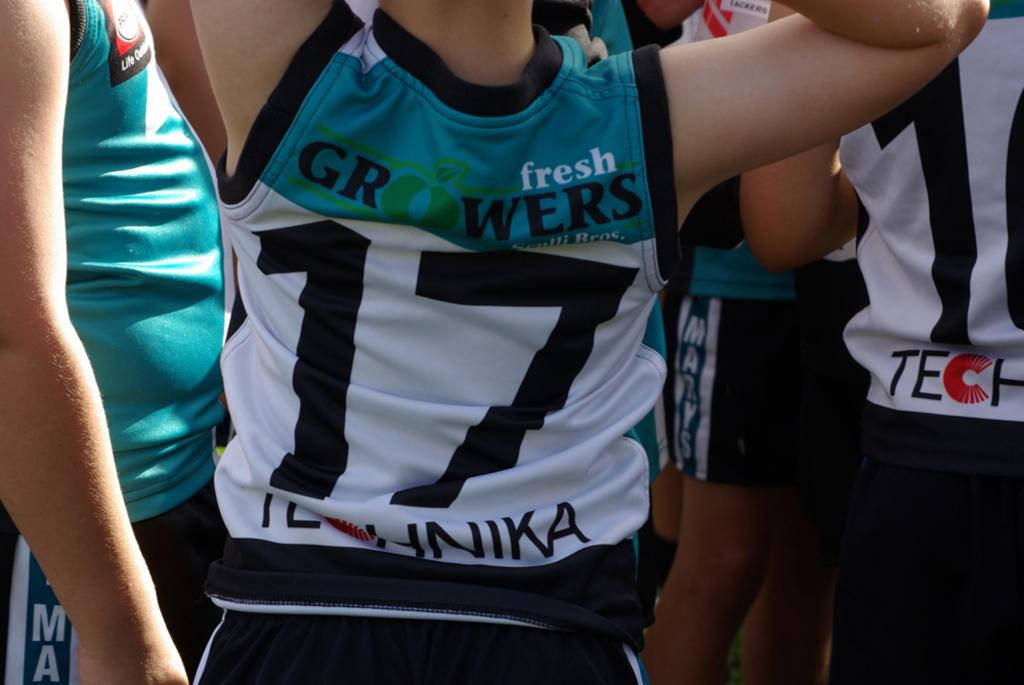<image>
Present a compact description of the photo's key features. an athlete wearing a blue and white number 17 jersey 